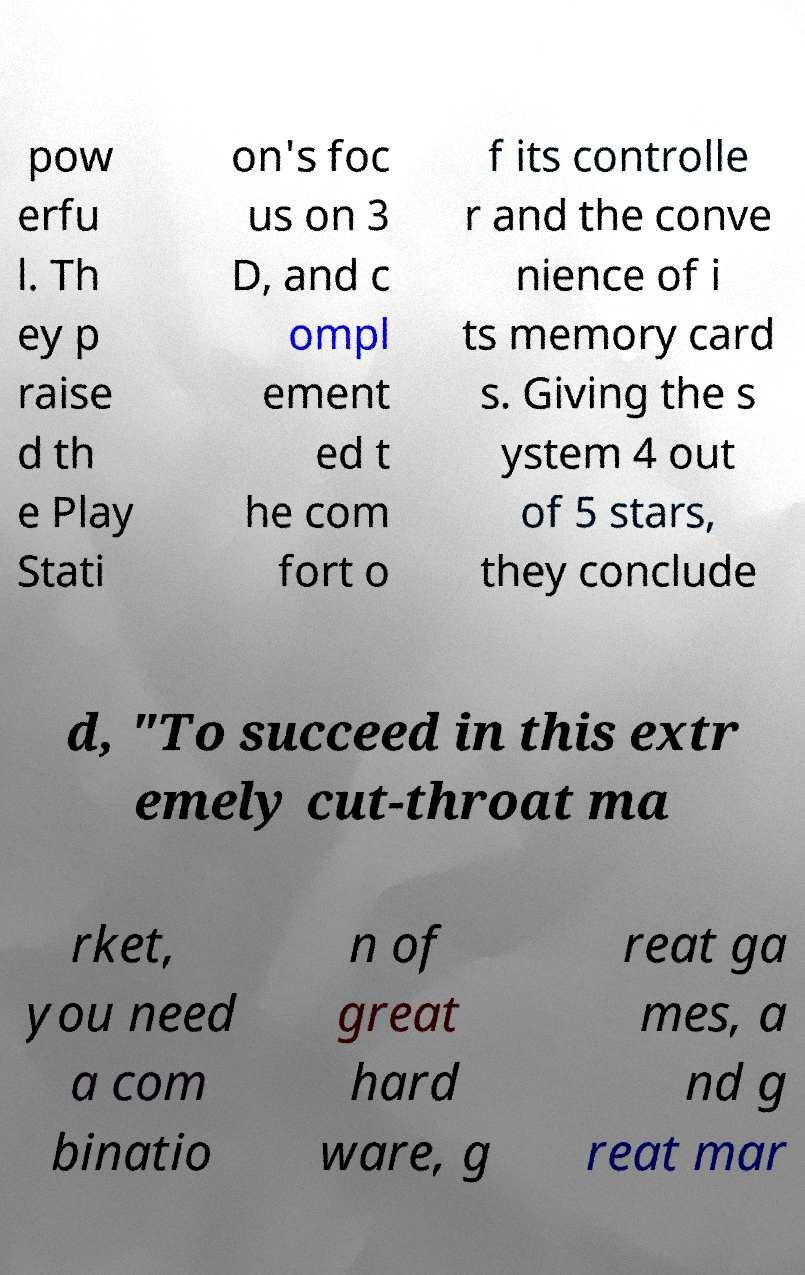Please identify and transcribe the text found in this image. pow erfu l. Th ey p raise d th e Play Stati on's foc us on 3 D, and c ompl ement ed t he com fort o f its controlle r and the conve nience of i ts memory card s. Giving the s ystem 4 out of 5 stars, they conclude d, "To succeed in this extr emely cut-throat ma rket, you need a com binatio n of great hard ware, g reat ga mes, a nd g reat mar 